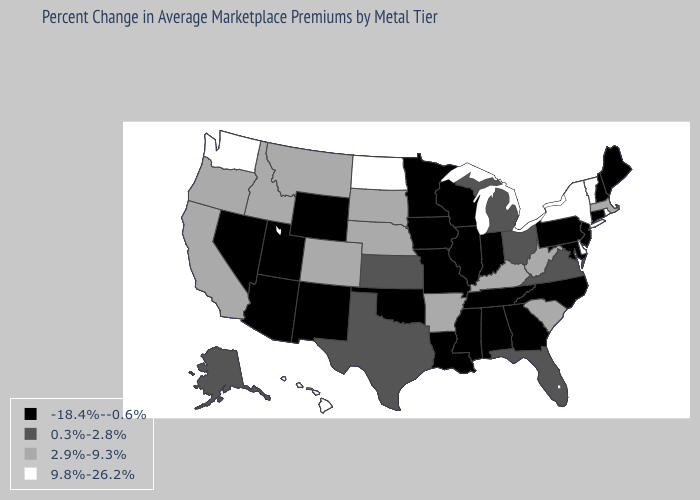Name the states that have a value in the range 2.9%-9.3%?
Keep it brief. Arkansas, California, Colorado, Idaho, Kentucky, Massachusetts, Montana, Nebraska, Oregon, South Carolina, South Dakota, West Virginia. Does Kansas have a higher value than Louisiana?
Write a very short answer. Yes. Which states hav the highest value in the MidWest?
Keep it brief. North Dakota. Which states have the lowest value in the MidWest?
Concise answer only. Illinois, Indiana, Iowa, Minnesota, Missouri, Wisconsin. What is the value of Illinois?
Give a very brief answer. -18.4%--0.6%. What is the value of New Jersey?
Keep it brief. -18.4%--0.6%. Does Massachusetts have the highest value in the Northeast?
Give a very brief answer. No. Among the states that border Kansas , does Oklahoma have the highest value?
Be succinct. No. How many symbols are there in the legend?
Concise answer only. 4. What is the lowest value in states that border New Mexico?
Concise answer only. -18.4%--0.6%. What is the value of Tennessee?
Short answer required. -18.4%--0.6%. Does Delaware have the highest value in the USA?
Answer briefly. Yes. Name the states that have a value in the range 9.8%-26.2%?
Keep it brief. Delaware, Hawaii, New York, North Dakota, Rhode Island, Vermont, Washington. What is the value of South Dakota?
Be succinct. 2.9%-9.3%. Among the states that border North Dakota , does Montana have the lowest value?
Answer briefly. No. 